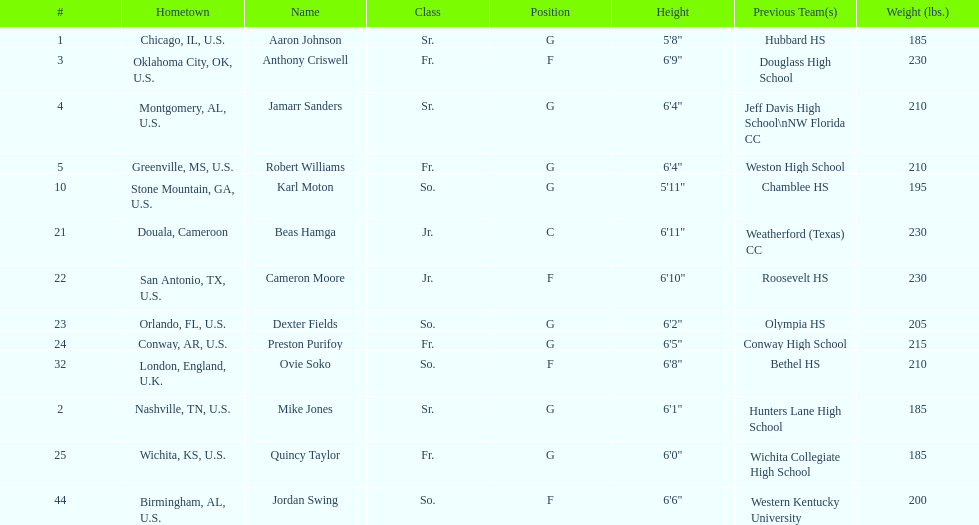How many players come from alabama? 2. 